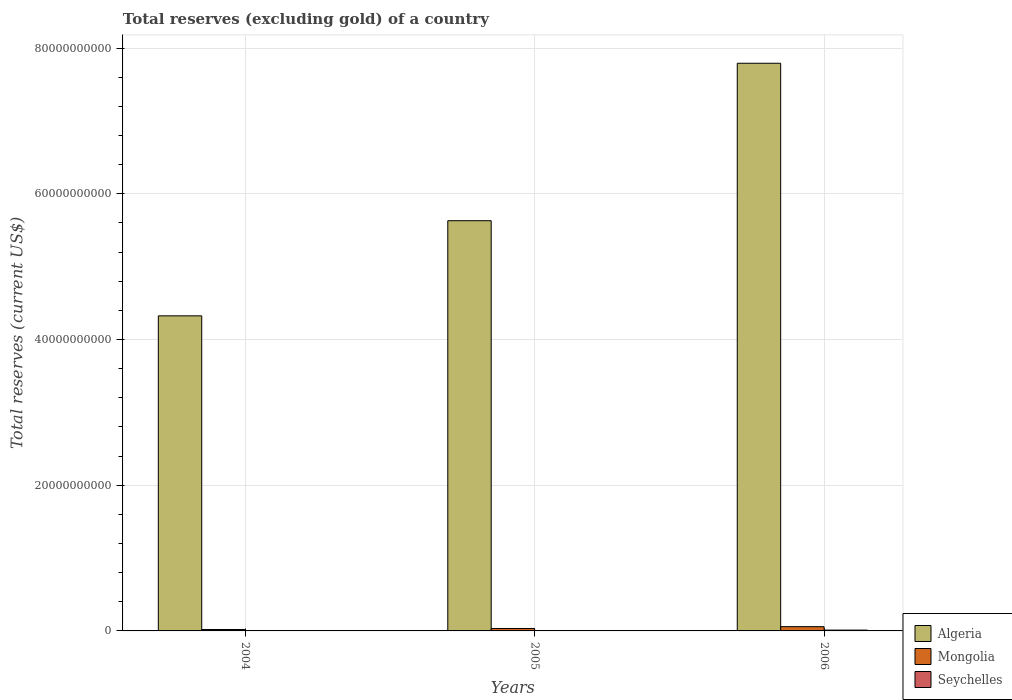How many groups of bars are there?
Keep it short and to the point. 3. Are the number of bars on each tick of the X-axis equal?
Provide a short and direct response. Yes. What is the label of the 1st group of bars from the left?
Offer a terse response. 2004. In how many cases, is the number of bars for a given year not equal to the number of legend labels?
Make the answer very short. 0. What is the total reserves (excluding gold) in Algeria in 2006?
Your answer should be very brief. 7.79e+1. Across all years, what is the maximum total reserves (excluding gold) in Seychelles?
Offer a very short reply. 1.13e+08. Across all years, what is the minimum total reserves (excluding gold) in Mongolia?
Provide a short and direct response. 1.94e+08. What is the total total reserves (excluding gold) in Seychelles in the graph?
Offer a terse response. 2.04e+08. What is the difference between the total reserves (excluding gold) in Seychelles in 2005 and that in 2006?
Your answer should be compact. -5.67e+07. What is the difference between the total reserves (excluding gold) in Algeria in 2005 and the total reserves (excluding gold) in Mongolia in 2004?
Offer a terse response. 5.61e+1. What is the average total reserves (excluding gold) in Seychelles per year?
Keep it short and to the point. 6.79e+07. In the year 2006, what is the difference between the total reserves (excluding gold) in Algeria and total reserves (excluding gold) in Seychelles?
Your answer should be compact. 7.78e+1. What is the ratio of the total reserves (excluding gold) in Seychelles in 2005 to that in 2006?
Ensure brevity in your answer.  0.5. What is the difference between the highest and the second highest total reserves (excluding gold) in Mongolia?
Your answer should be compact. 2.50e+08. What is the difference between the highest and the lowest total reserves (excluding gold) in Algeria?
Provide a succinct answer. 3.47e+1. In how many years, is the total reserves (excluding gold) in Algeria greater than the average total reserves (excluding gold) in Algeria taken over all years?
Your answer should be very brief. 1. What does the 1st bar from the left in 2004 represents?
Your answer should be compact. Algeria. What does the 3rd bar from the right in 2004 represents?
Provide a succinct answer. Algeria. Is it the case that in every year, the sum of the total reserves (excluding gold) in Seychelles and total reserves (excluding gold) in Mongolia is greater than the total reserves (excluding gold) in Algeria?
Make the answer very short. No. What is the difference between two consecutive major ticks on the Y-axis?
Offer a very short reply. 2.00e+1. Are the values on the major ticks of Y-axis written in scientific E-notation?
Give a very brief answer. No. Where does the legend appear in the graph?
Offer a very short reply. Bottom right. How many legend labels are there?
Offer a very short reply. 3. What is the title of the graph?
Give a very brief answer. Total reserves (excluding gold) of a country. Does "Congo (Democratic)" appear as one of the legend labels in the graph?
Ensure brevity in your answer.  No. What is the label or title of the Y-axis?
Provide a short and direct response. Total reserves (current US$). What is the Total reserves (current US$) in Algeria in 2004?
Provide a short and direct response. 4.32e+1. What is the Total reserves (current US$) of Mongolia in 2004?
Make the answer very short. 1.94e+08. What is the Total reserves (current US$) in Seychelles in 2004?
Keep it short and to the point. 3.46e+07. What is the Total reserves (current US$) in Algeria in 2005?
Provide a short and direct response. 5.63e+1. What is the Total reserves (current US$) of Mongolia in 2005?
Provide a succinct answer. 3.33e+08. What is the Total reserves (current US$) of Seychelles in 2005?
Your answer should be compact. 5.62e+07. What is the Total reserves (current US$) in Algeria in 2006?
Your response must be concise. 7.79e+1. What is the Total reserves (current US$) in Mongolia in 2006?
Offer a very short reply. 5.83e+08. What is the Total reserves (current US$) in Seychelles in 2006?
Ensure brevity in your answer.  1.13e+08. Across all years, what is the maximum Total reserves (current US$) of Algeria?
Provide a short and direct response. 7.79e+1. Across all years, what is the maximum Total reserves (current US$) of Mongolia?
Ensure brevity in your answer.  5.83e+08. Across all years, what is the maximum Total reserves (current US$) of Seychelles?
Give a very brief answer. 1.13e+08. Across all years, what is the minimum Total reserves (current US$) in Algeria?
Offer a very short reply. 4.32e+1. Across all years, what is the minimum Total reserves (current US$) of Mongolia?
Provide a succinct answer. 1.94e+08. Across all years, what is the minimum Total reserves (current US$) of Seychelles?
Keep it short and to the point. 3.46e+07. What is the total Total reserves (current US$) in Algeria in the graph?
Provide a short and direct response. 1.77e+11. What is the total Total reserves (current US$) in Mongolia in the graph?
Ensure brevity in your answer.  1.11e+09. What is the total Total reserves (current US$) in Seychelles in the graph?
Your response must be concise. 2.04e+08. What is the difference between the Total reserves (current US$) of Algeria in 2004 and that in 2005?
Your answer should be compact. -1.31e+1. What is the difference between the Total reserves (current US$) of Mongolia in 2004 and that in 2005?
Offer a terse response. -1.39e+08. What is the difference between the Total reserves (current US$) in Seychelles in 2004 and that in 2005?
Keep it short and to the point. -2.17e+07. What is the difference between the Total reserves (current US$) of Algeria in 2004 and that in 2006?
Your answer should be very brief. -3.47e+1. What is the difference between the Total reserves (current US$) in Mongolia in 2004 and that in 2006?
Ensure brevity in your answer.  -3.90e+08. What is the difference between the Total reserves (current US$) of Seychelles in 2004 and that in 2006?
Keep it short and to the point. -7.83e+07. What is the difference between the Total reserves (current US$) of Algeria in 2005 and that in 2006?
Your answer should be very brief. -2.16e+1. What is the difference between the Total reserves (current US$) of Mongolia in 2005 and that in 2006?
Keep it short and to the point. -2.50e+08. What is the difference between the Total reserves (current US$) of Seychelles in 2005 and that in 2006?
Your response must be concise. -5.67e+07. What is the difference between the Total reserves (current US$) in Algeria in 2004 and the Total reserves (current US$) in Mongolia in 2005?
Give a very brief answer. 4.29e+1. What is the difference between the Total reserves (current US$) of Algeria in 2004 and the Total reserves (current US$) of Seychelles in 2005?
Offer a terse response. 4.32e+1. What is the difference between the Total reserves (current US$) in Mongolia in 2004 and the Total reserves (current US$) in Seychelles in 2005?
Your answer should be compact. 1.37e+08. What is the difference between the Total reserves (current US$) in Algeria in 2004 and the Total reserves (current US$) in Mongolia in 2006?
Keep it short and to the point. 4.27e+1. What is the difference between the Total reserves (current US$) of Algeria in 2004 and the Total reserves (current US$) of Seychelles in 2006?
Make the answer very short. 4.31e+1. What is the difference between the Total reserves (current US$) of Mongolia in 2004 and the Total reserves (current US$) of Seychelles in 2006?
Offer a very short reply. 8.08e+07. What is the difference between the Total reserves (current US$) of Algeria in 2005 and the Total reserves (current US$) of Mongolia in 2006?
Your answer should be compact. 5.57e+1. What is the difference between the Total reserves (current US$) of Algeria in 2005 and the Total reserves (current US$) of Seychelles in 2006?
Keep it short and to the point. 5.62e+1. What is the difference between the Total reserves (current US$) of Mongolia in 2005 and the Total reserves (current US$) of Seychelles in 2006?
Your answer should be very brief. 2.20e+08. What is the average Total reserves (current US$) of Algeria per year?
Your answer should be very brief. 5.92e+1. What is the average Total reserves (current US$) of Mongolia per year?
Give a very brief answer. 3.70e+08. What is the average Total reserves (current US$) of Seychelles per year?
Provide a short and direct response. 6.79e+07. In the year 2004, what is the difference between the Total reserves (current US$) of Algeria and Total reserves (current US$) of Mongolia?
Provide a short and direct response. 4.31e+1. In the year 2004, what is the difference between the Total reserves (current US$) in Algeria and Total reserves (current US$) in Seychelles?
Provide a succinct answer. 4.32e+1. In the year 2004, what is the difference between the Total reserves (current US$) of Mongolia and Total reserves (current US$) of Seychelles?
Offer a very short reply. 1.59e+08. In the year 2005, what is the difference between the Total reserves (current US$) in Algeria and Total reserves (current US$) in Mongolia?
Make the answer very short. 5.60e+1. In the year 2005, what is the difference between the Total reserves (current US$) of Algeria and Total reserves (current US$) of Seychelles?
Your answer should be very brief. 5.62e+1. In the year 2005, what is the difference between the Total reserves (current US$) of Mongolia and Total reserves (current US$) of Seychelles?
Give a very brief answer. 2.77e+08. In the year 2006, what is the difference between the Total reserves (current US$) in Algeria and Total reserves (current US$) in Mongolia?
Provide a succinct answer. 7.73e+1. In the year 2006, what is the difference between the Total reserves (current US$) in Algeria and Total reserves (current US$) in Seychelles?
Your answer should be compact. 7.78e+1. In the year 2006, what is the difference between the Total reserves (current US$) in Mongolia and Total reserves (current US$) in Seychelles?
Provide a succinct answer. 4.70e+08. What is the ratio of the Total reserves (current US$) in Algeria in 2004 to that in 2005?
Give a very brief answer. 0.77. What is the ratio of the Total reserves (current US$) of Mongolia in 2004 to that in 2005?
Give a very brief answer. 0.58. What is the ratio of the Total reserves (current US$) in Seychelles in 2004 to that in 2005?
Your answer should be very brief. 0.61. What is the ratio of the Total reserves (current US$) in Algeria in 2004 to that in 2006?
Offer a terse response. 0.56. What is the ratio of the Total reserves (current US$) of Mongolia in 2004 to that in 2006?
Offer a terse response. 0.33. What is the ratio of the Total reserves (current US$) of Seychelles in 2004 to that in 2006?
Your answer should be compact. 0.31. What is the ratio of the Total reserves (current US$) in Algeria in 2005 to that in 2006?
Your answer should be very brief. 0.72. What is the ratio of the Total reserves (current US$) of Mongolia in 2005 to that in 2006?
Give a very brief answer. 0.57. What is the ratio of the Total reserves (current US$) of Seychelles in 2005 to that in 2006?
Your response must be concise. 0.5. What is the difference between the highest and the second highest Total reserves (current US$) of Algeria?
Provide a succinct answer. 2.16e+1. What is the difference between the highest and the second highest Total reserves (current US$) in Mongolia?
Provide a succinct answer. 2.50e+08. What is the difference between the highest and the second highest Total reserves (current US$) of Seychelles?
Your answer should be compact. 5.67e+07. What is the difference between the highest and the lowest Total reserves (current US$) of Algeria?
Provide a succinct answer. 3.47e+1. What is the difference between the highest and the lowest Total reserves (current US$) in Mongolia?
Make the answer very short. 3.90e+08. What is the difference between the highest and the lowest Total reserves (current US$) of Seychelles?
Your response must be concise. 7.83e+07. 